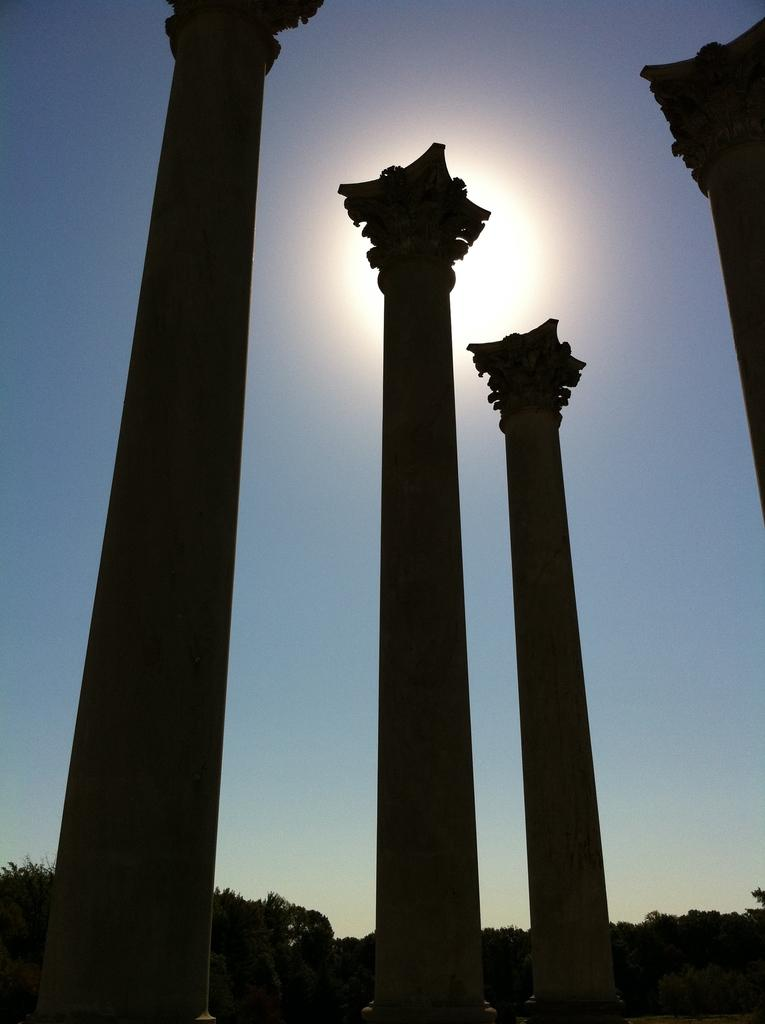What architectural features can be seen in the image? There are pillars in the image. What type of vegetation is present in the image? There are trees in the image. What can be seen in the background of the image? The sky is visible in the background of the image. How many feet are visible in the image? There are no feet present in the image. What type of business can be seen in the image? There is no business depicted in the image; it features pillars and trees. 